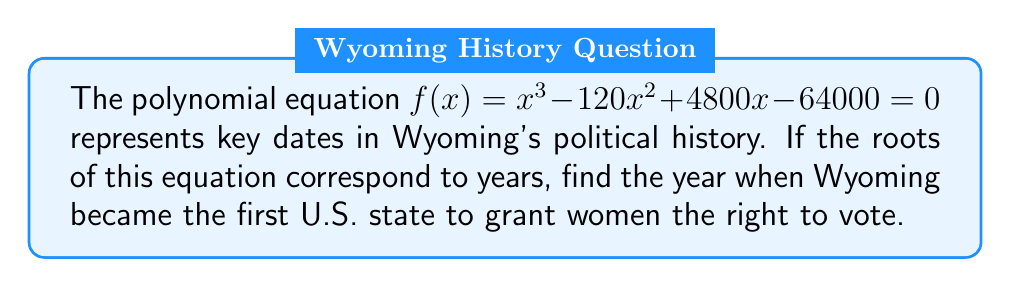Can you solve this math problem? Let's approach this step-by-step:

1) First, we need to factor the polynomial to find its roots. The equation is:

   $x^3 - 120x^2 + 4800x - 64000 = 0$

2) This is a cubic equation, and we can solve it by factoring or using the rational root theorem. After factoring, we get:

   $(x - 80)(x - 20)(x - 40) = 0$

3) The roots of this equation are 80, 20, and 40. Since these represent years, we need to add 1800 to each root to get the actual years:

   1880, 1820, and 1840

4) Now, we need to identify which of these years corresponds to Wyoming granting women the right to vote.

5) From historical knowledge, we know that Wyoming was the first U.S. state to grant women the right to vote in 1869, before it even became a state.

6) The closest year to 1869 among our options is 1880.

Therefore, the year 1880 (corresponding to the root 80) is the answer to our question.
Answer: 1880 